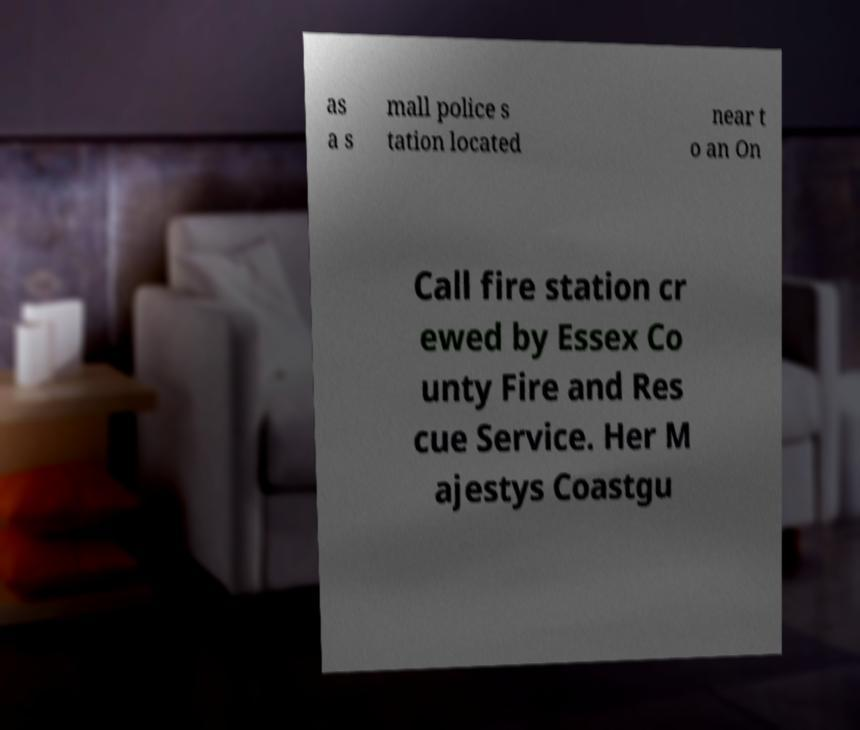Could you extract and type out the text from this image? as a s mall police s tation located near t o an On Call fire station cr ewed by Essex Co unty Fire and Res cue Service. Her M ajestys Coastgu 